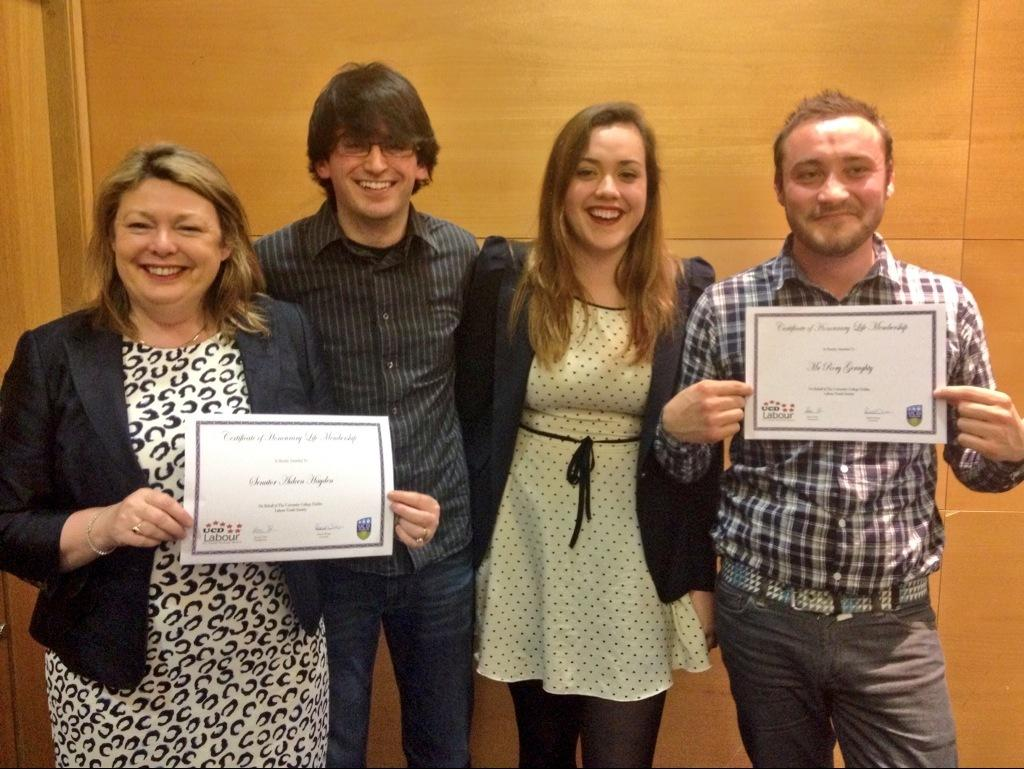What are the people in the image doing? There are people standing in the image. What are some of the people holding? Some of the people are holding certificates. What can be seen in the background of the image? There is a wooden wall in the background of the image. Can you hear anyone coughing in the image? There is no audible information in the image, so it is not possible to determine if anyone is coughing. 